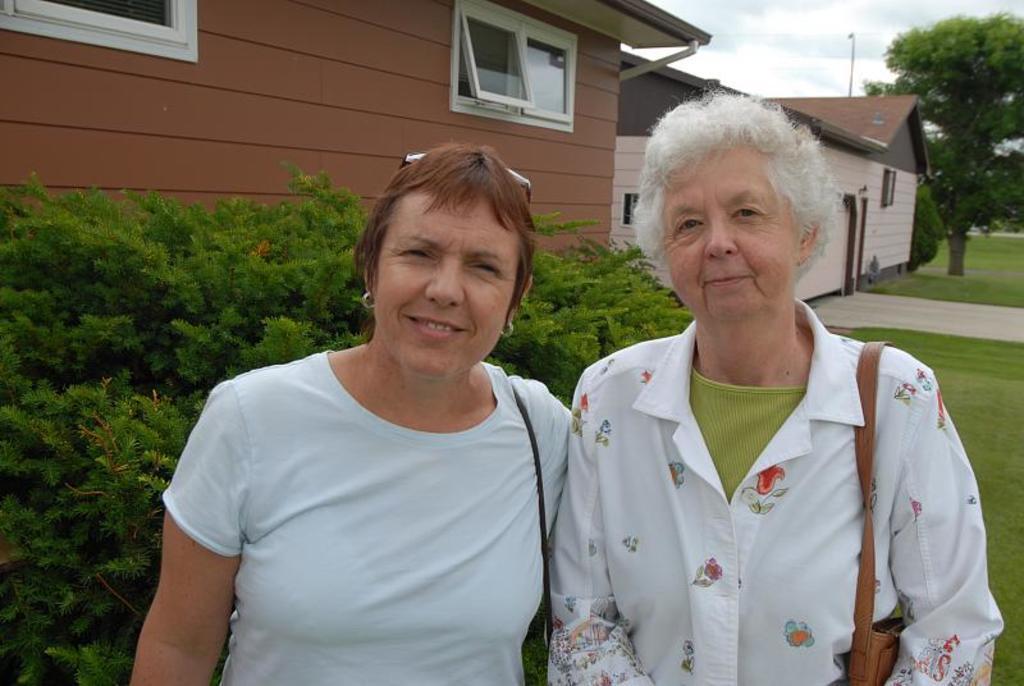In one or two sentences, can you explain what this image depicts? This image is taken outdoors. At the top of the image there is a sky with clouds. In the background there are a few houses with walls, windows and doors and there are a few trees and plants. In the middle of the image two women are standing on the ground. On the right side of the image there is a ground with grass on it. 